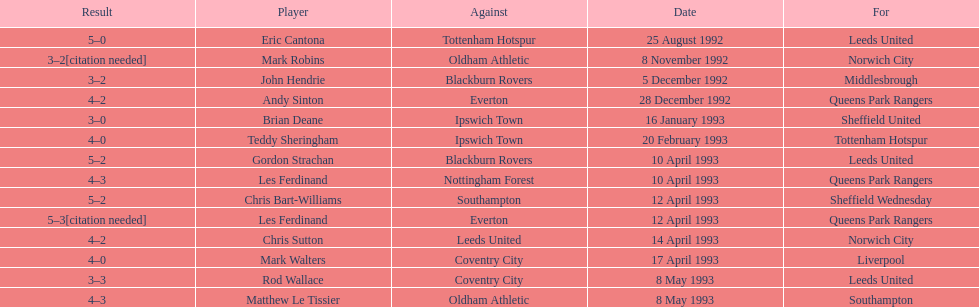Which team did liverpool play against? Coventry City. 